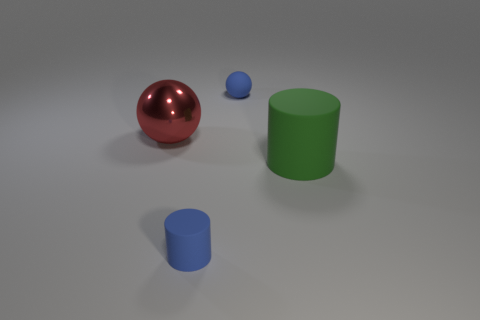Are there any other things that have the same material as the big red sphere?
Ensure brevity in your answer.  No. What number of objects are matte balls or large brown metal spheres?
Provide a succinct answer. 1. What number of big green objects have the same material as the tiny blue cylinder?
Ensure brevity in your answer.  1. Are there fewer large green cylinders than small blue objects?
Make the answer very short. Yes. Are the cylinder right of the small sphere and the large ball made of the same material?
Keep it short and to the point. No. What number of spheres are blue objects or rubber things?
Provide a short and direct response. 1. What is the shape of the thing that is to the left of the large matte cylinder and on the right side of the tiny matte cylinder?
Ensure brevity in your answer.  Sphere. What is the color of the object behind the sphere left of the blue thing that is behind the red metal sphere?
Your answer should be very brief. Blue. Is the number of small matte objects that are to the left of the big red metallic thing less than the number of tiny rubber balls?
Offer a terse response. Yes. There is a tiny blue thing behind the small rubber cylinder; does it have the same shape as the big thing right of the large red metallic thing?
Make the answer very short. No. 